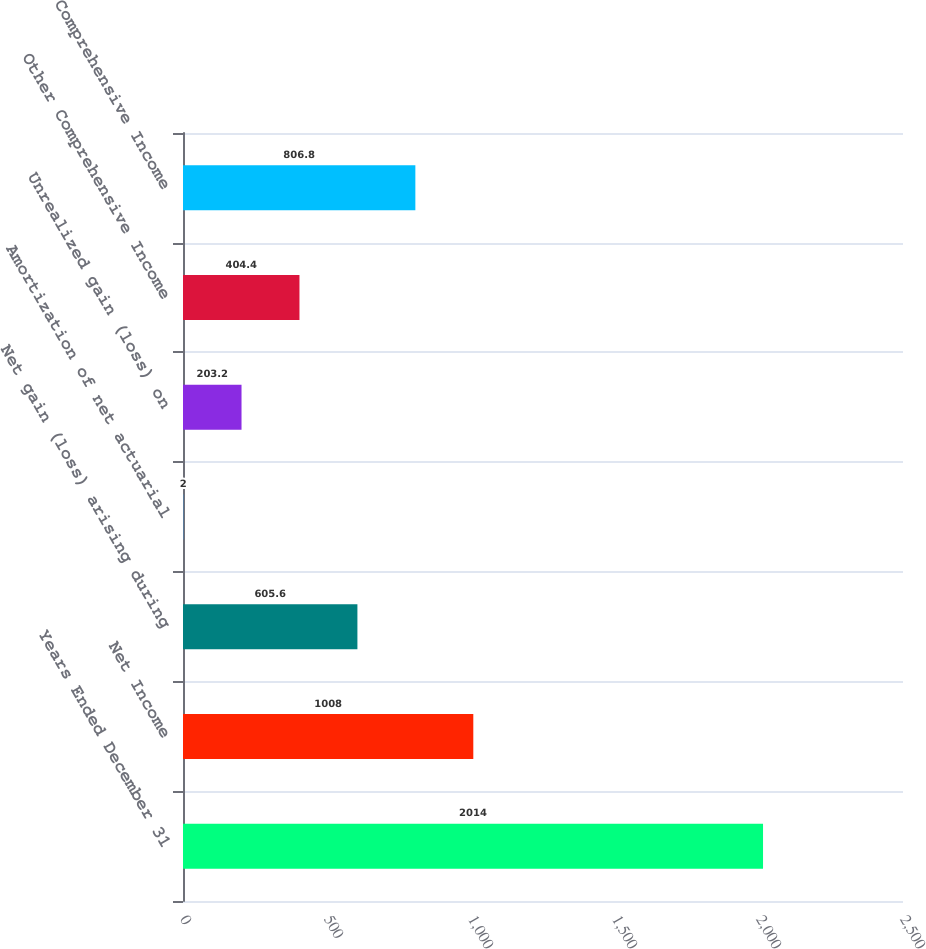Convert chart. <chart><loc_0><loc_0><loc_500><loc_500><bar_chart><fcel>Years Ended December 31<fcel>Net Income<fcel>Net gain (loss) arising during<fcel>Amortization of net actuarial<fcel>Unrealized gain (loss) on<fcel>Other Comprehensive Income<fcel>Comprehensive Income<nl><fcel>2014<fcel>1008<fcel>605.6<fcel>2<fcel>203.2<fcel>404.4<fcel>806.8<nl></chart> 